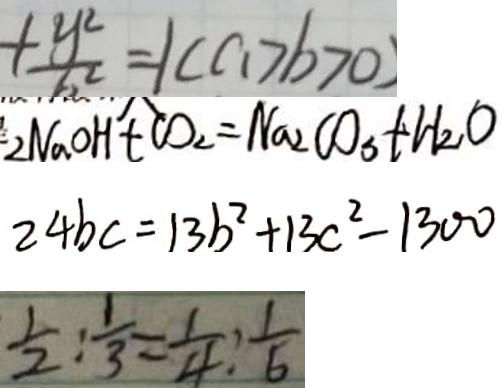<formula> <loc_0><loc_0><loc_500><loc_500>+ \frac { y ^ { 2 } } { b ^ { 2 } } = 1 ( a > b > 0 ) 
 2 N a O H + C O _ { 2 } = N a _ { 2 } C O _ { 3 } + H _ { 2 } O 
 2 4 b c = 1 3 b ^ { 2 } + 1 3 c ^ { 2 } - 1 3 0 0 
 \frac { 1 } { 2 } : \frac { 1 } { 3 } = \frac { 1 } { 4 } : \frac { 1 } { 6 }</formula> 